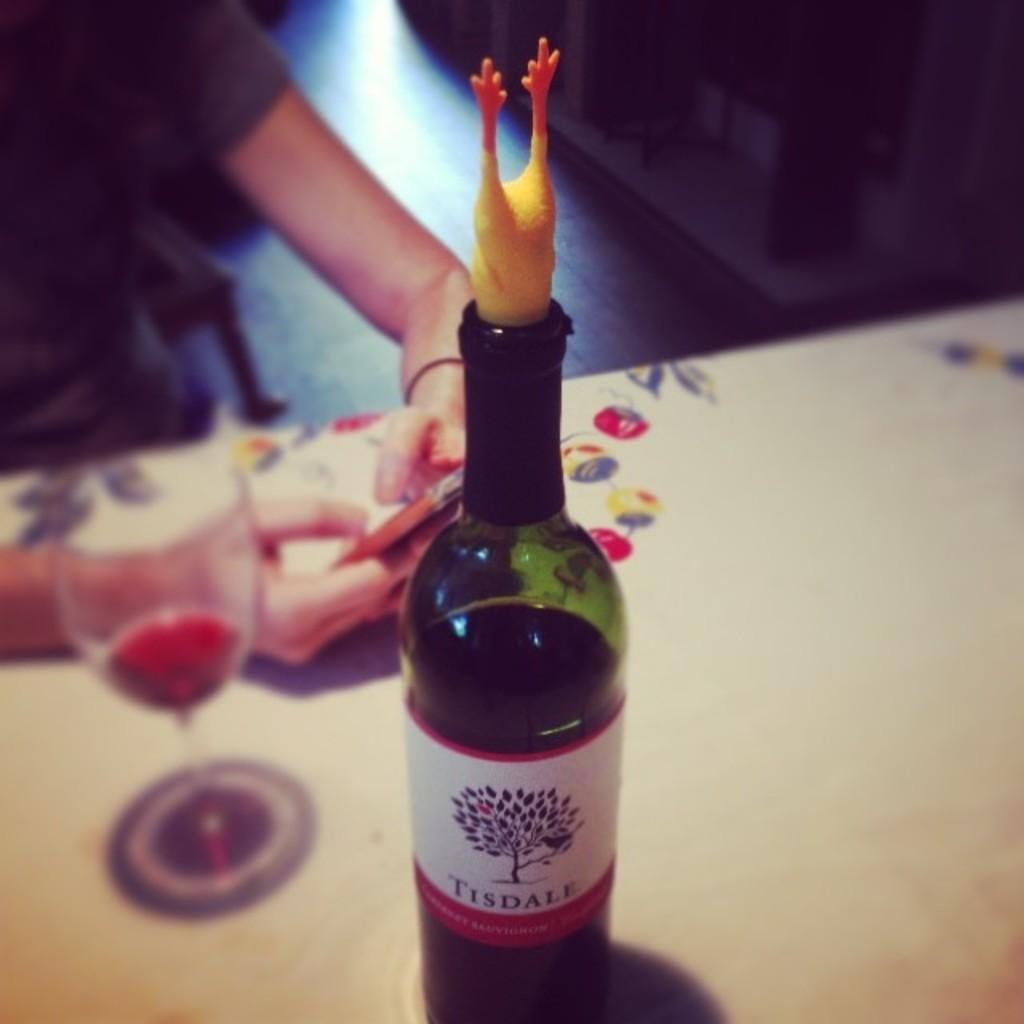<image>
Create a compact narrative representing the image presented. a bottle that has tisdale written on it 